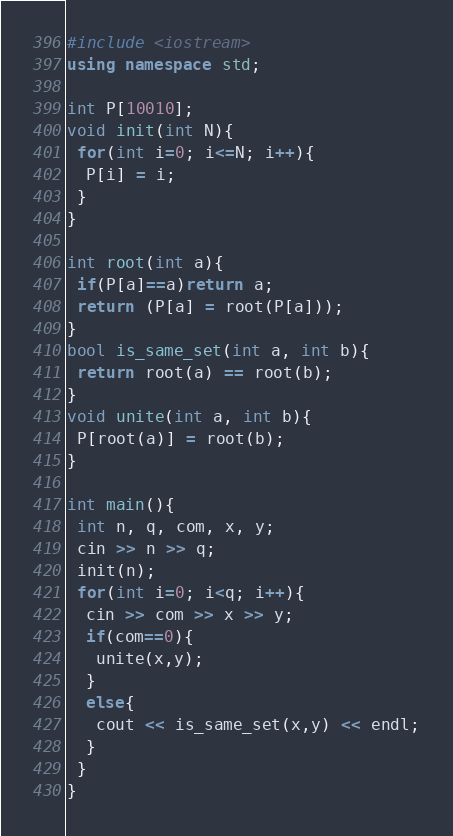<code> <loc_0><loc_0><loc_500><loc_500><_C++_>#include <iostream>
using namespace std;

int P[10010];
void init(int N){
 for(int i=0; i<=N; i++){
  P[i] = i;
 }
}

int root(int a){
 if(P[a]==a)return a;
 return (P[a] = root(P[a]));
}
bool is_same_set(int a, int b){
 return root(a) == root(b);
}
void unite(int a, int b){
 P[root(a)] = root(b);
}

int main(){
 int n, q, com, x, y;
 cin >> n >> q;
 init(n);
 for(int i=0; i<q; i++){
  cin >> com >> x >> y;
  if(com==0){
   unite(x,y);
  }
  else{
   cout << is_same_set(x,y) << endl;
  }
 }
}</code> 